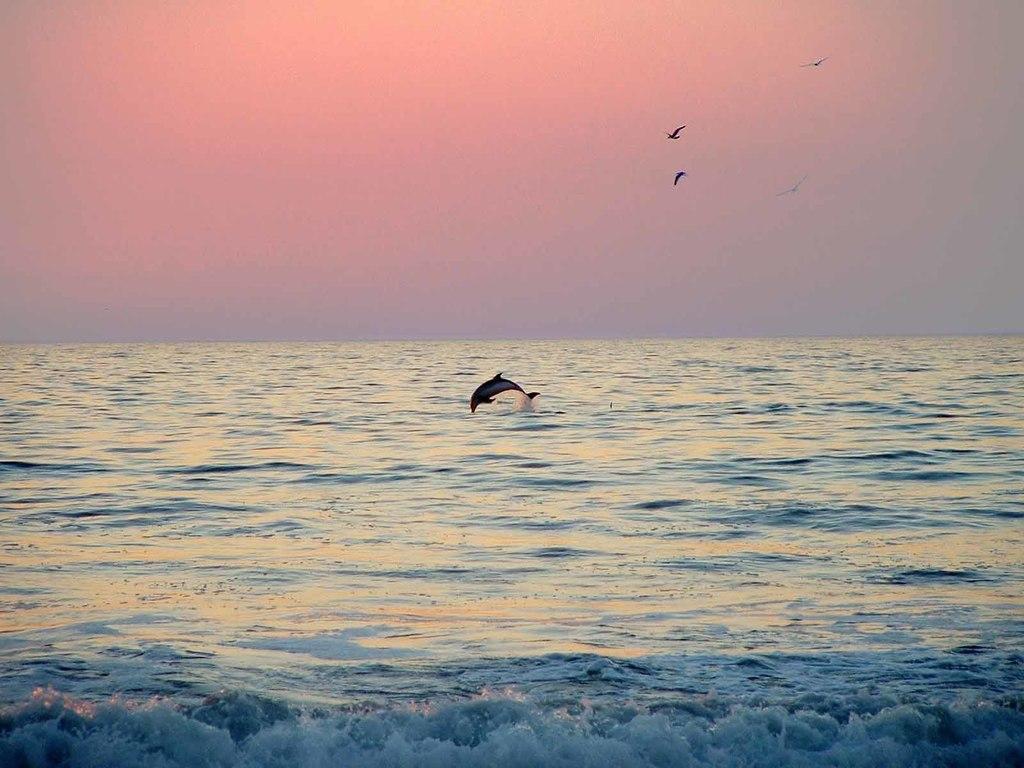Describe this image in one or two sentences. This picture is clicked outside the city. In the foreground we can see a water body and a dolphin. In the background there is a sky and we can see some birds are flying in the sky. 